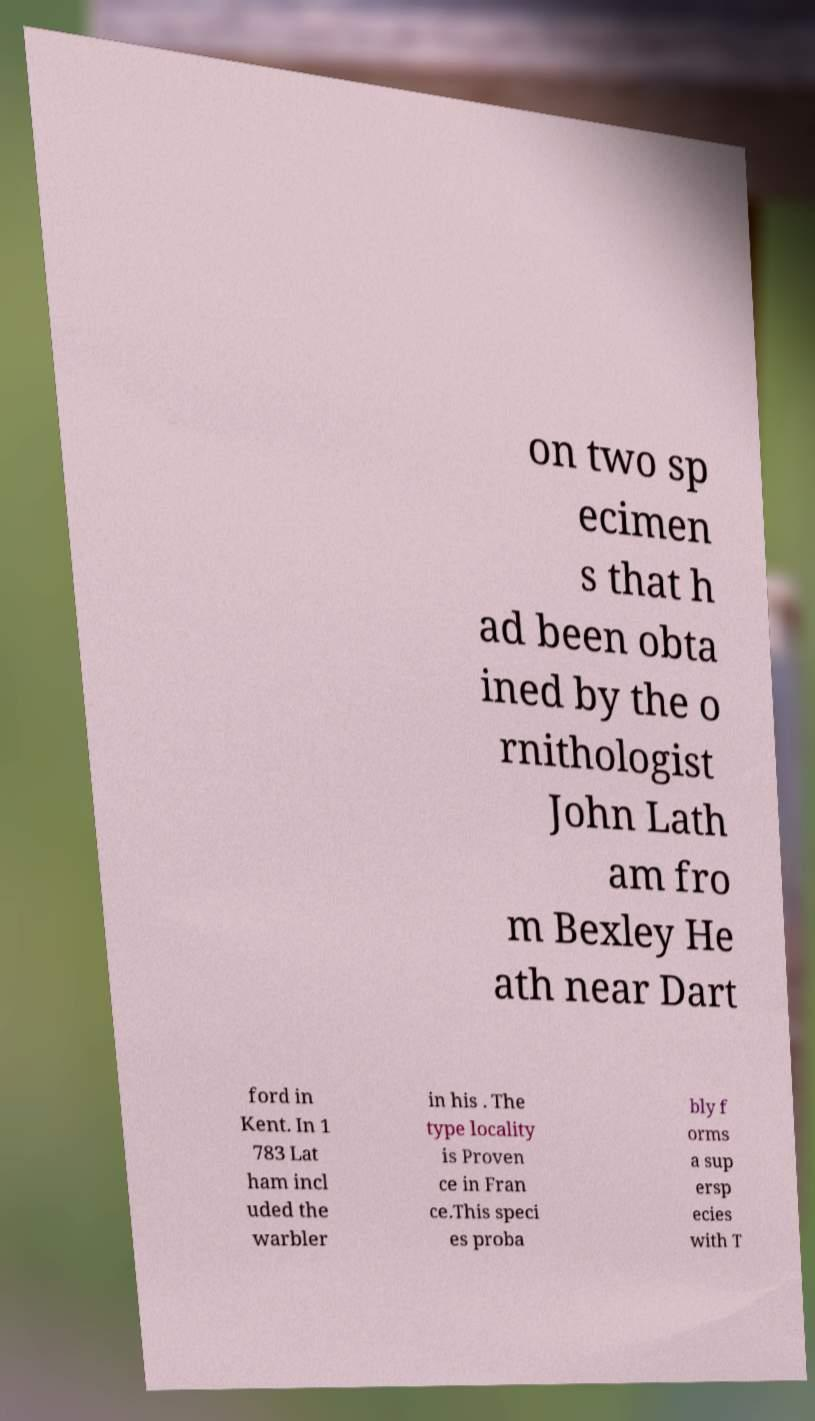Can you accurately transcribe the text from the provided image for me? on two sp ecimen s that h ad been obta ined by the o rnithologist John Lath am fro m Bexley He ath near Dart ford in Kent. In 1 783 Lat ham incl uded the warbler in his . The type locality is Proven ce in Fran ce.This speci es proba bly f orms a sup ersp ecies with T 